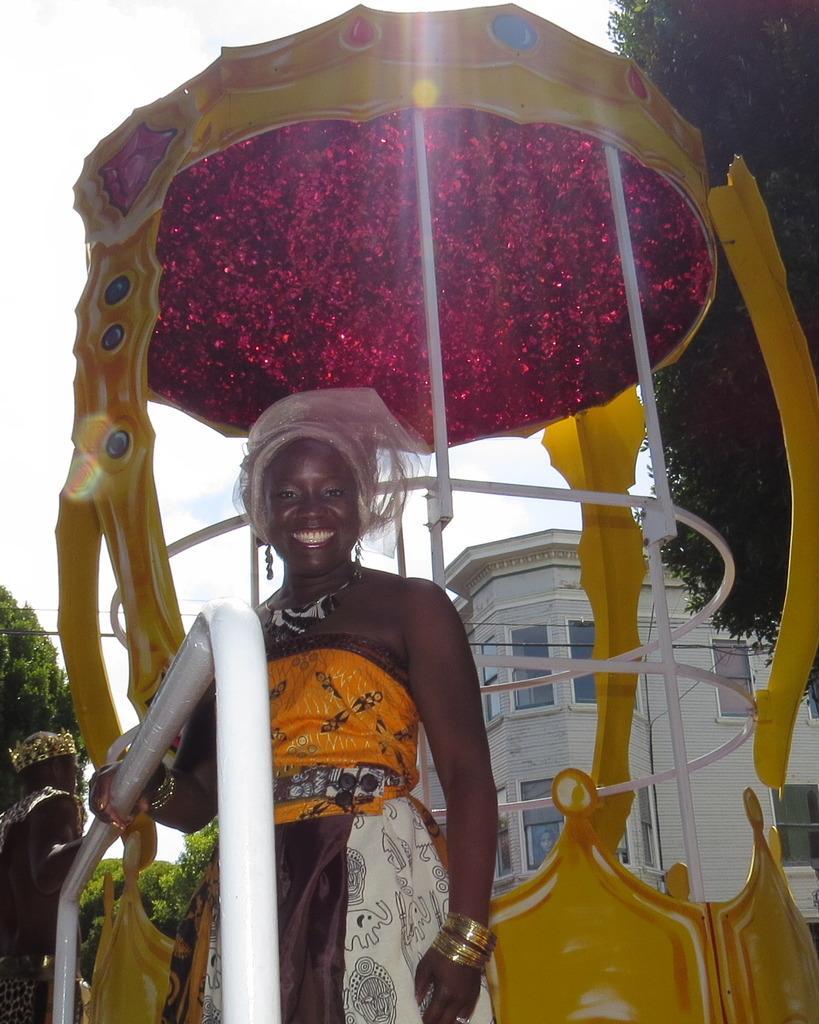Could you give a brief overview of what you see in this image? In the foreground I can see a woman is standing on a chariot and is holding a metal rod in hand. In the background I can see trees, buildings, windows, plants, person and the sky. This image is taken may be during a day. 